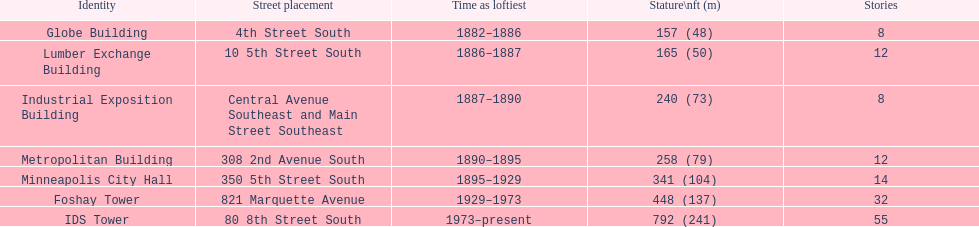How long did the lumber exchange building stand as the tallest building? 1 year. 